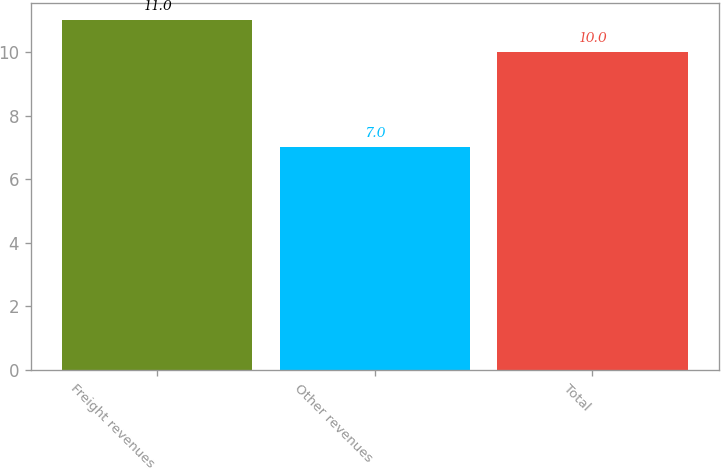Convert chart to OTSL. <chart><loc_0><loc_0><loc_500><loc_500><bar_chart><fcel>Freight revenues<fcel>Other revenues<fcel>Total<nl><fcel>11<fcel>7<fcel>10<nl></chart> 